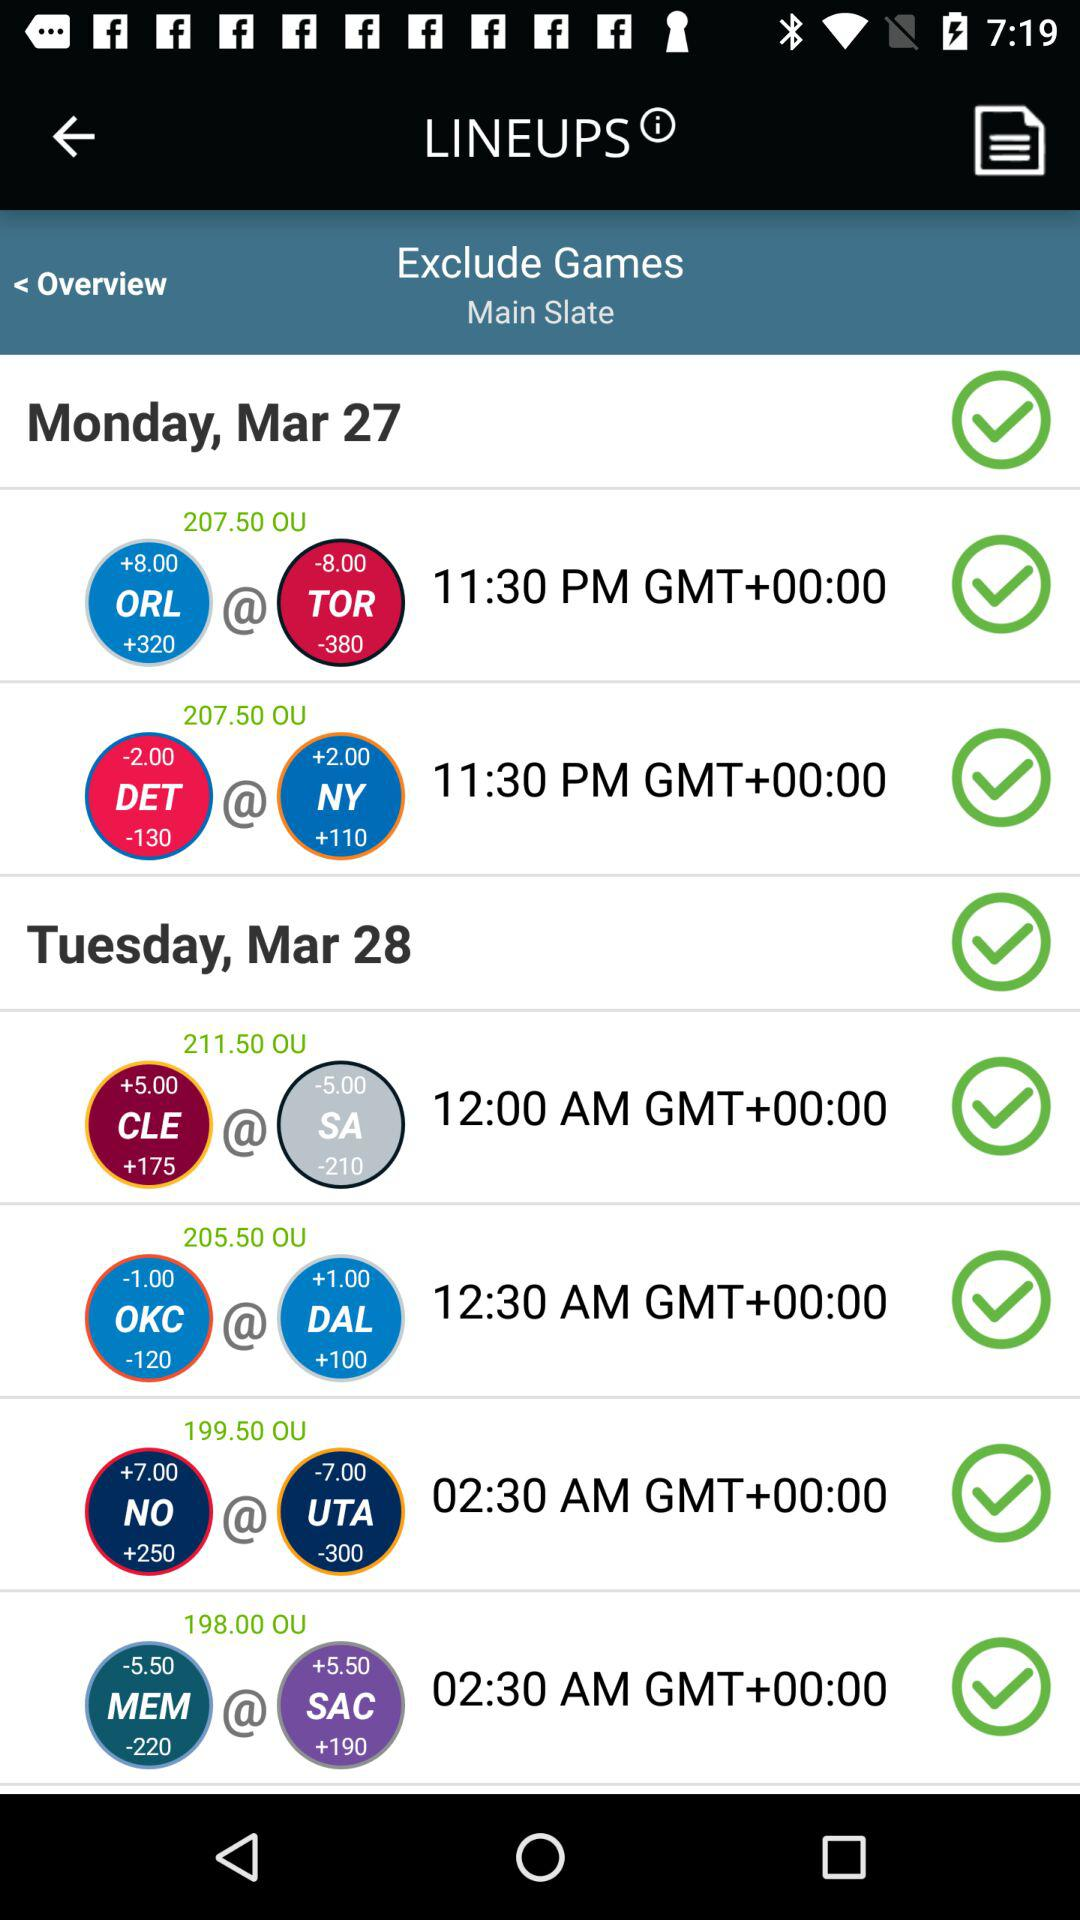What is the application Name?
When the provided information is insufficient, respond with <no answer>. <no answer> 